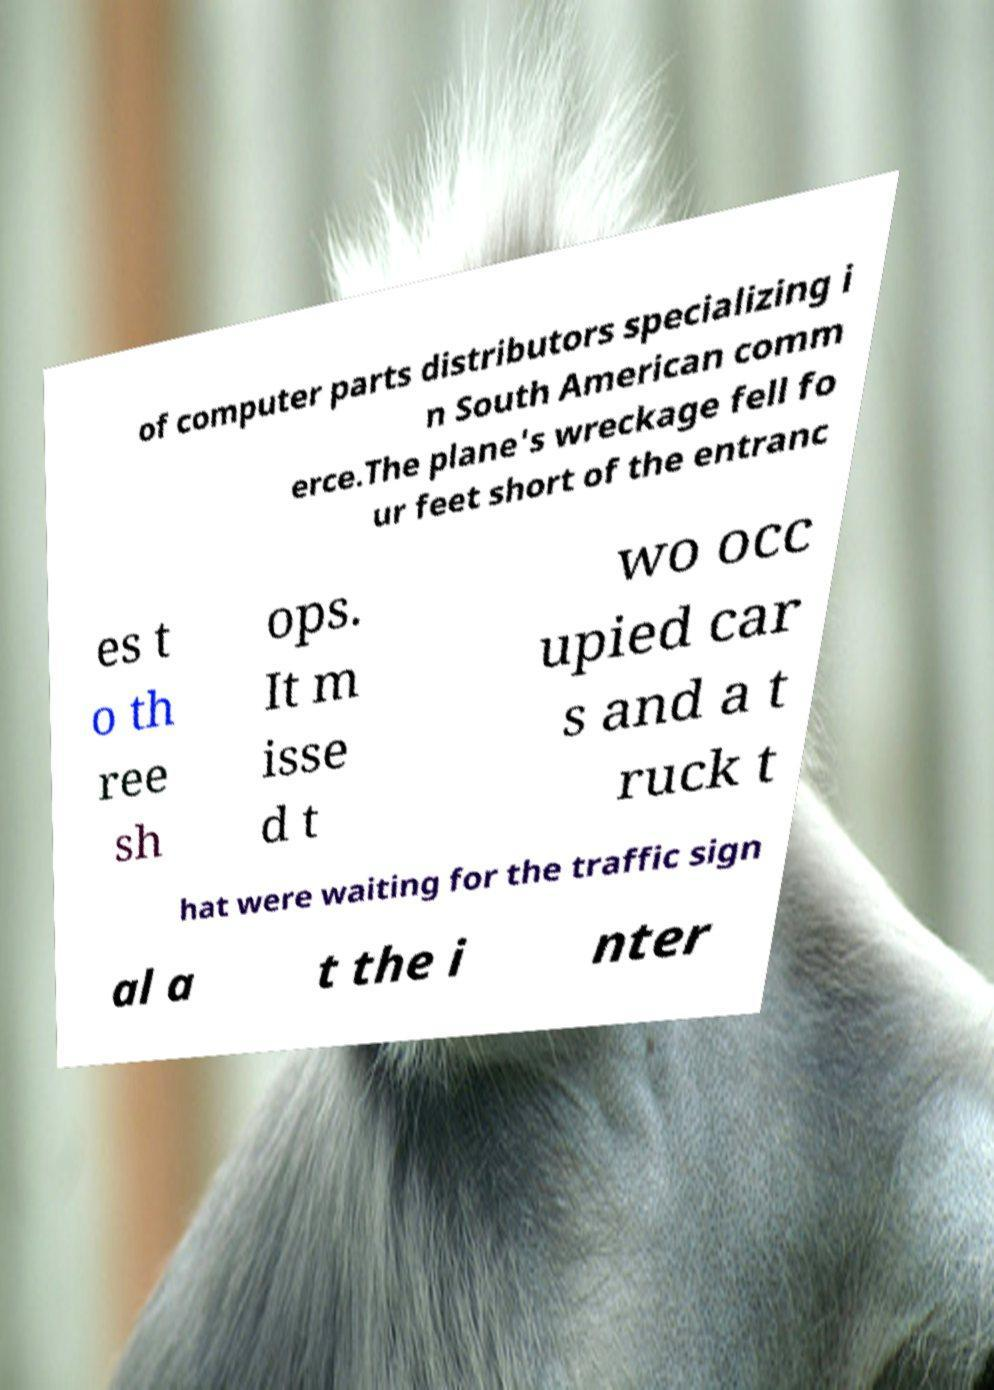Please read and relay the text visible in this image. What does it say? of computer parts distributors specializing i n South American comm erce.The plane's wreckage fell fo ur feet short of the entranc es t o th ree sh ops. It m isse d t wo occ upied car s and a t ruck t hat were waiting for the traffic sign al a t the i nter 